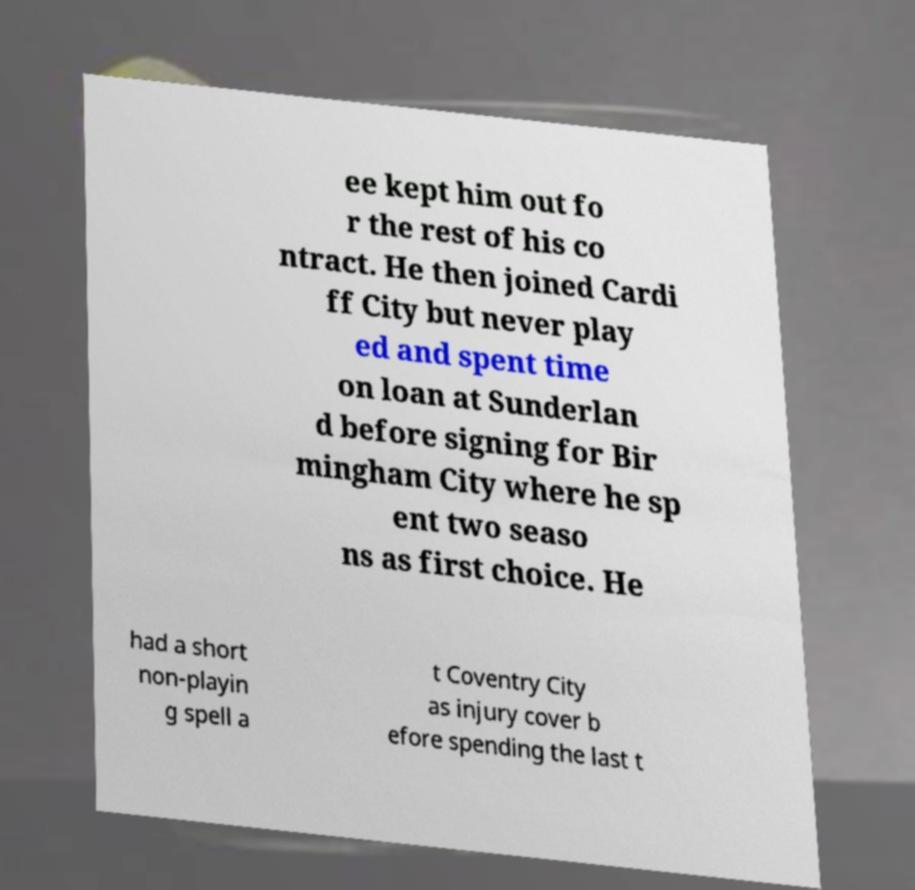Can you read and provide the text displayed in the image?This photo seems to have some interesting text. Can you extract and type it out for me? ee kept him out fo r the rest of his co ntract. He then joined Cardi ff City but never play ed and spent time on loan at Sunderlan d before signing for Bir mingham City where he sp ent two seaso ns as first choice. He had a short non-playin g spell a t Coventry City as injury cover b efore spending the last t 